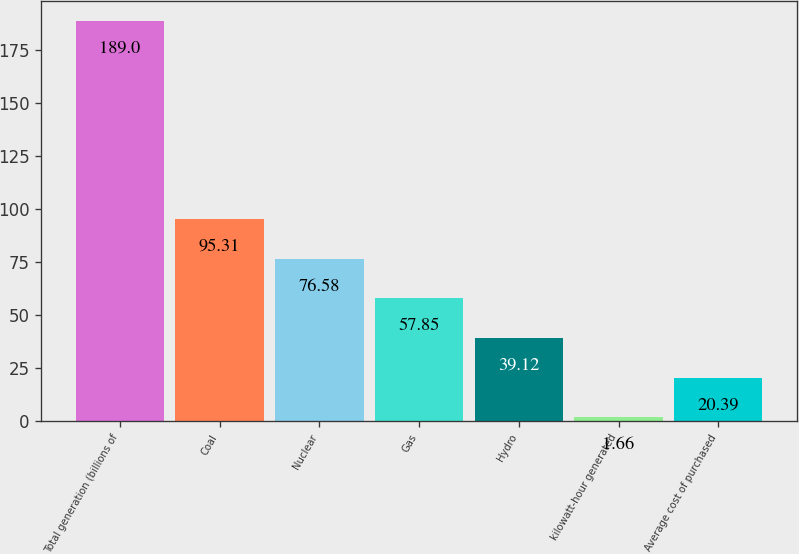Convert chart. <chart><loc_0><loc_0><loc_500><loc_500><bar_chart><fcel>Total generation (billions of<fcel>Coal<fcel>Nuclear<fcel>Gas<fcel>Hydro<fcel>kilowatt-hour generated<fcel>Average cost of purchased<nl><fcel>189<fcel>95.31<fcel>76.58<fcel>57.85<fcel>39.12<fcel>1.66<fcel>20.39<nl></chart> 